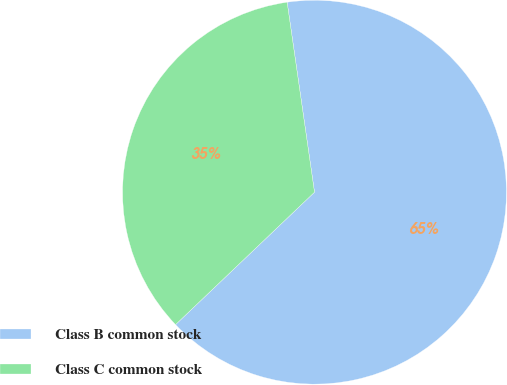<chart> <loc_0><loc_0><loc_500><loc_500><pie_chart><fcel>Class B common stock<fcel>Class C common stock<nl><fcel>65.16%<fcel>34.84%<nl></chart> 